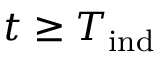<formula> <loc_0><loc_0><loc_500><loc_500>t \geq T _ { i n d }</formula> 